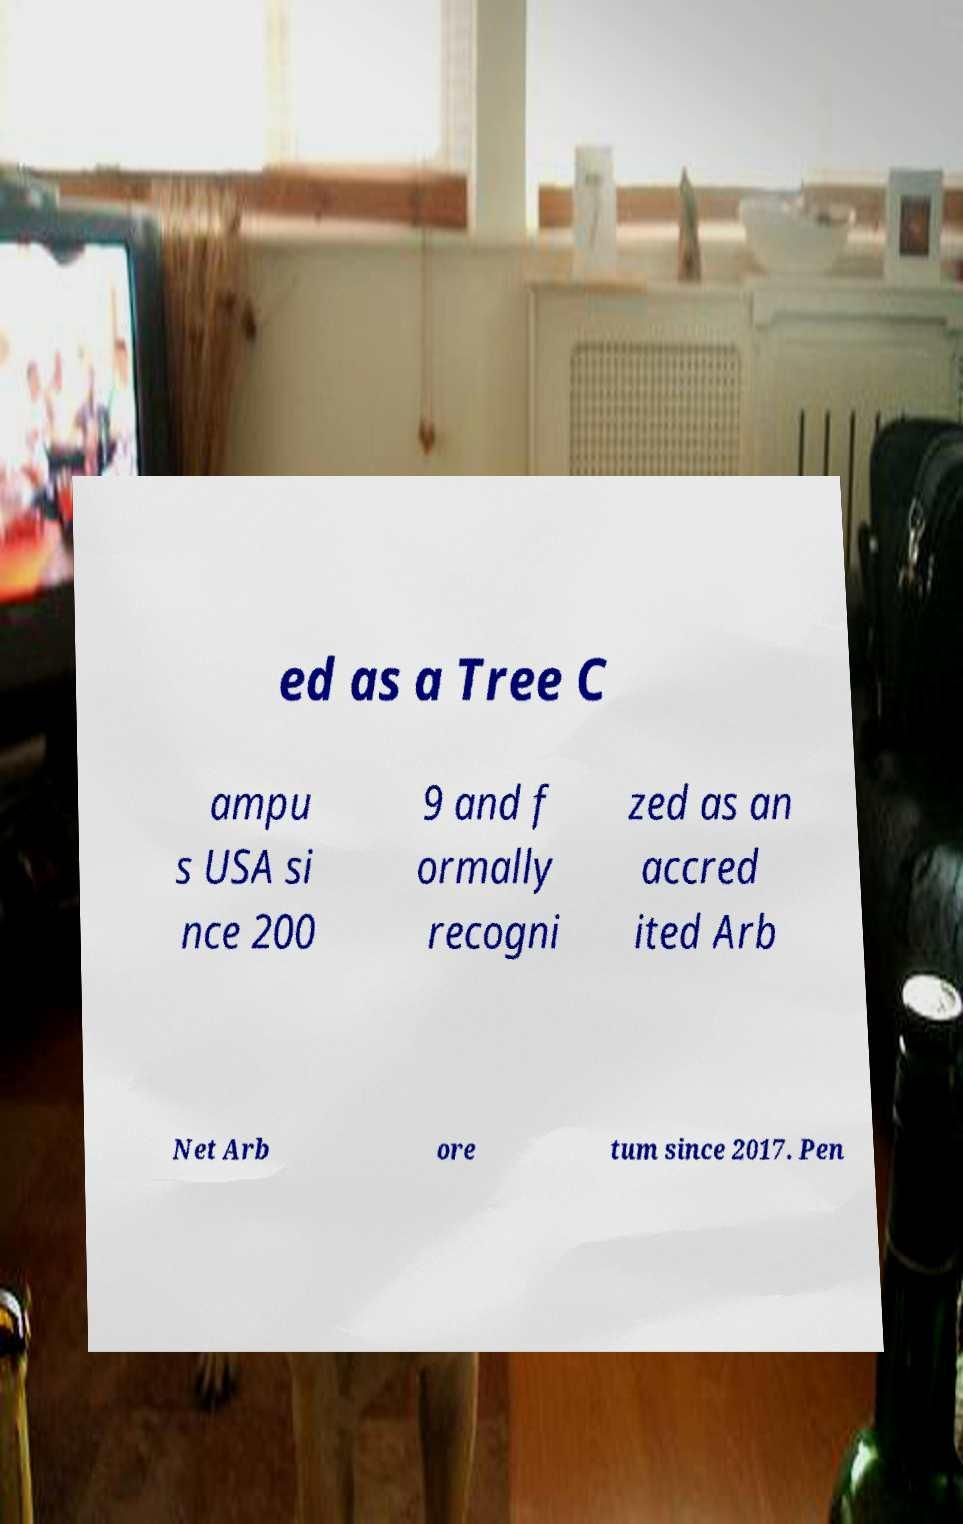Can you read and provide the text displayed in the image?This photo seems to have some interesting text. Can you extract and type it out for me? ed as a Tree C ampu s USA si nce 200 9 and f ormally recogni zed as an accred ited Arb Net Arb ore tum since 2017. Pen 